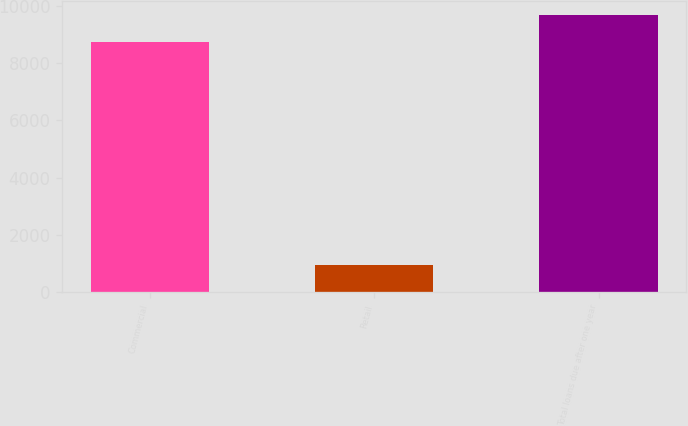Convert chart. <chart><loc_0><loc_0><loc_500><loc_500><bar_chart><fcel>Commercial<fcel>Retail<fcel>Total loans due after one year<nl><fcel>8745.9<fcel>931<fcel>9676.9<nl></chart> 